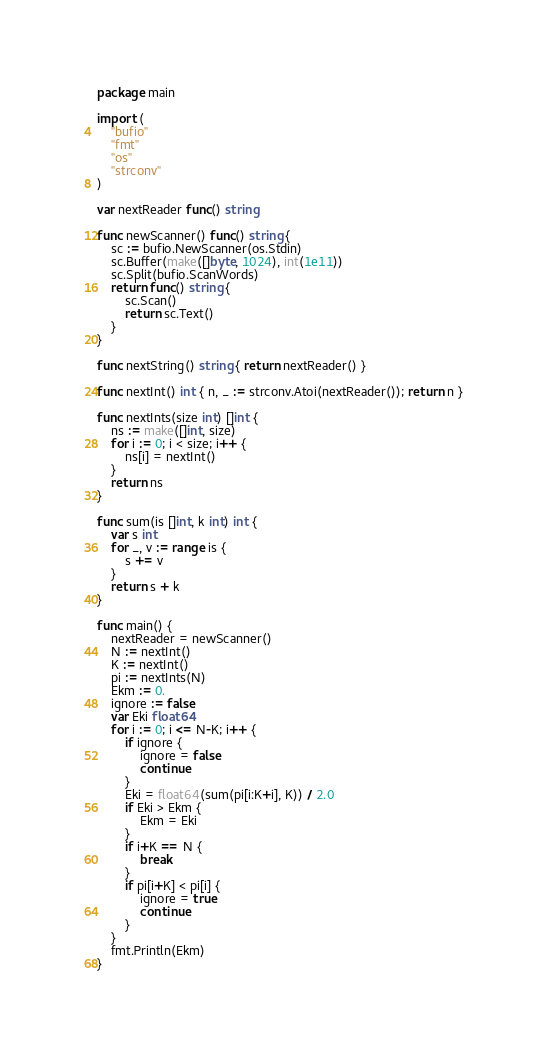<code> <loc_0><loc_0><loc_500><loc_500><_Go_>package main

import (
	"bufio"
	"fmt"
	"os"
	"strconv"
)

var nextReader func() string

func newScanner() func() string {
	sc := bufio.NewScanner(os.Stdin)
	sc.Buffer(make([]byte, 1024), int(1e11))
	sc.Split(bufio.ScanWords)
	return func() string {
		sc.Scan()
		return sc.Text()
	}
}

func nextString() string { return nextReader() }

func nextInt() int { n, _ := strconv.Atoi(nextReader()); return n }

func nextInts(size int) []int {
	ns := make([]int, size)
	for i := 0; i < size; i++ {
		ns[i] = nextInt()
	}
	return ns
}

func sum(is []int, k int) int {
	var s int
	for _, v := range is {
		s += v
	}
	return s + k
}

func main() {
	nextReader = newScanner()
	N := nextInt()
	K := nextInt()
	pi := nextInts(N)
	Ekm := 0.
	ignore := false
	var Eki float64
	for i := 0; i <= N-K; i++ {
		if ignore {
			ignore = false
			continue
		}
		Eki = float64(sum(pi[i:K+i], K)) / 2.0
		if Eki > Ekm {
			Ekm = Eki
		}
		if i+K == N {
			break
		}
		if pi[i+K] < pi[i] {
			ignore = true
			continue
		}
	}
	fmt.Println(Ekm)
}
</code> 